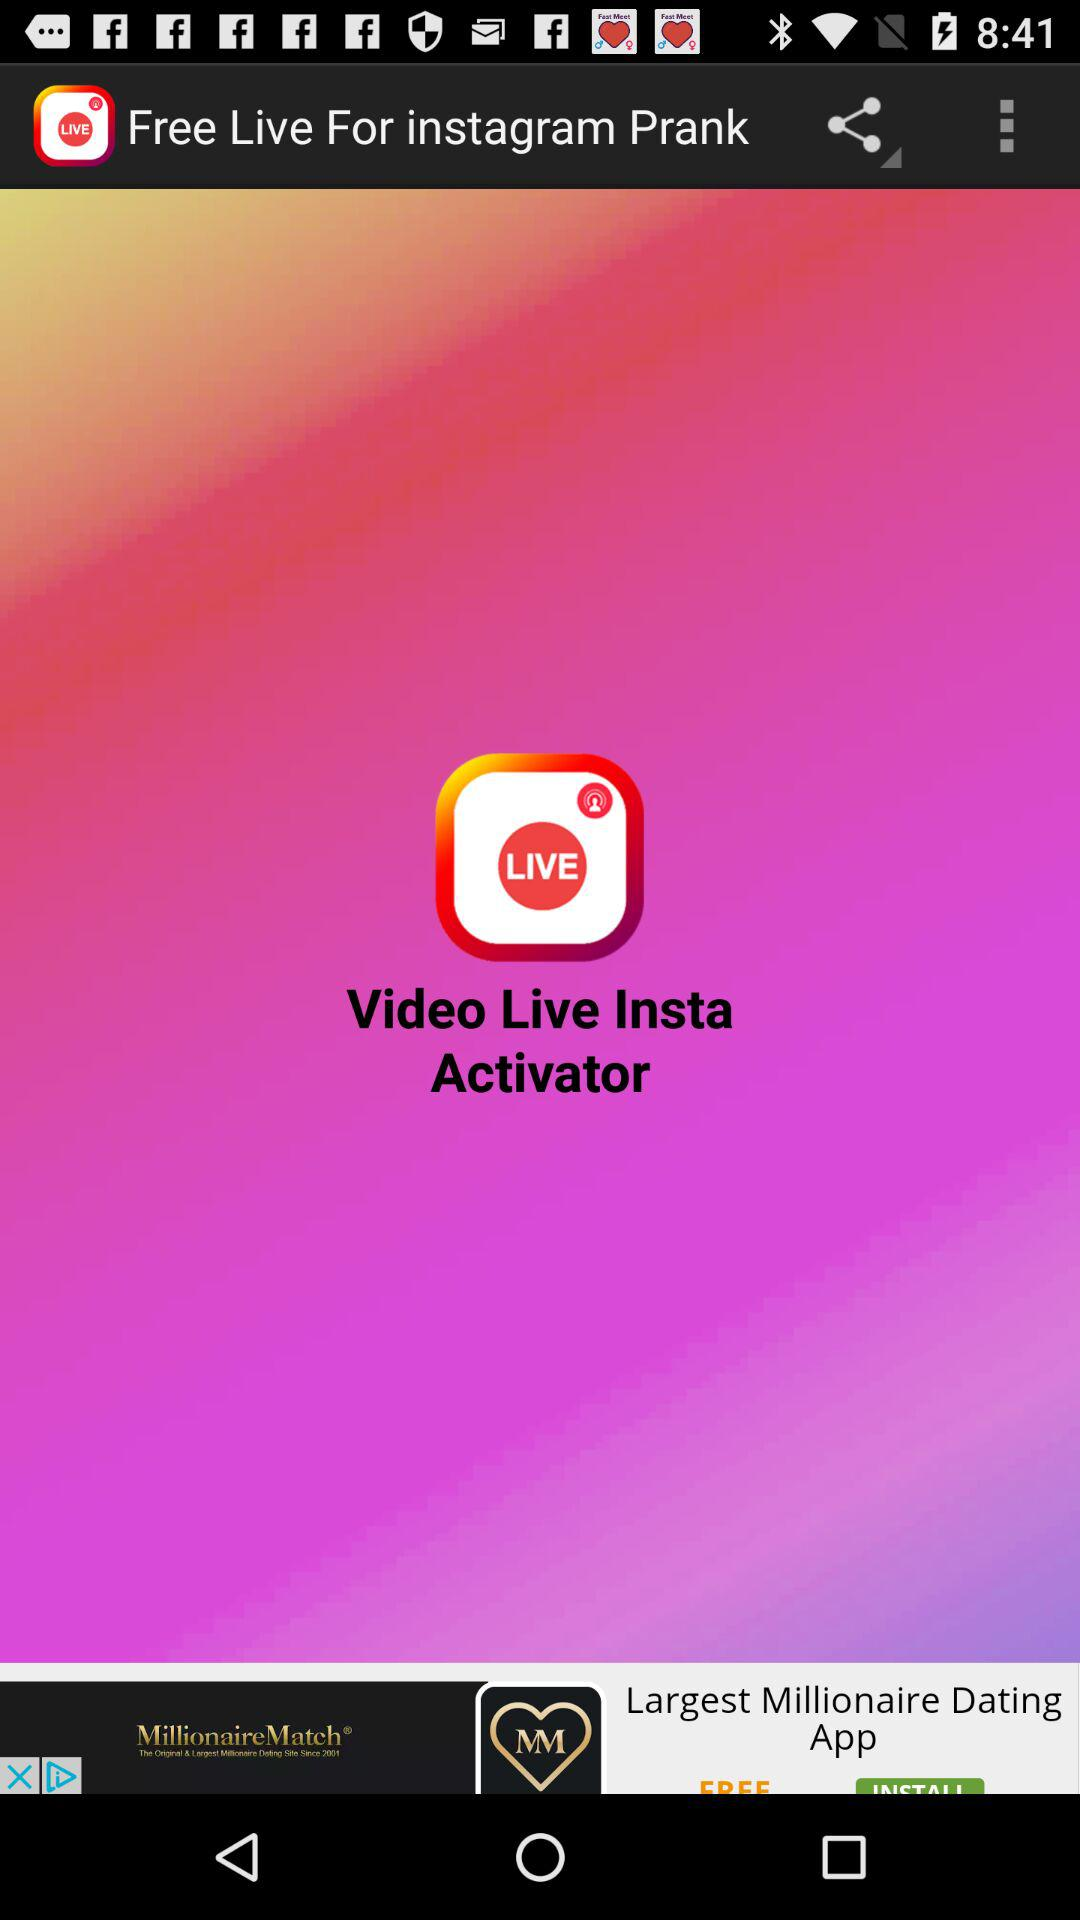What is the name of the application? The application name is "Free Live For instagram Prank". 